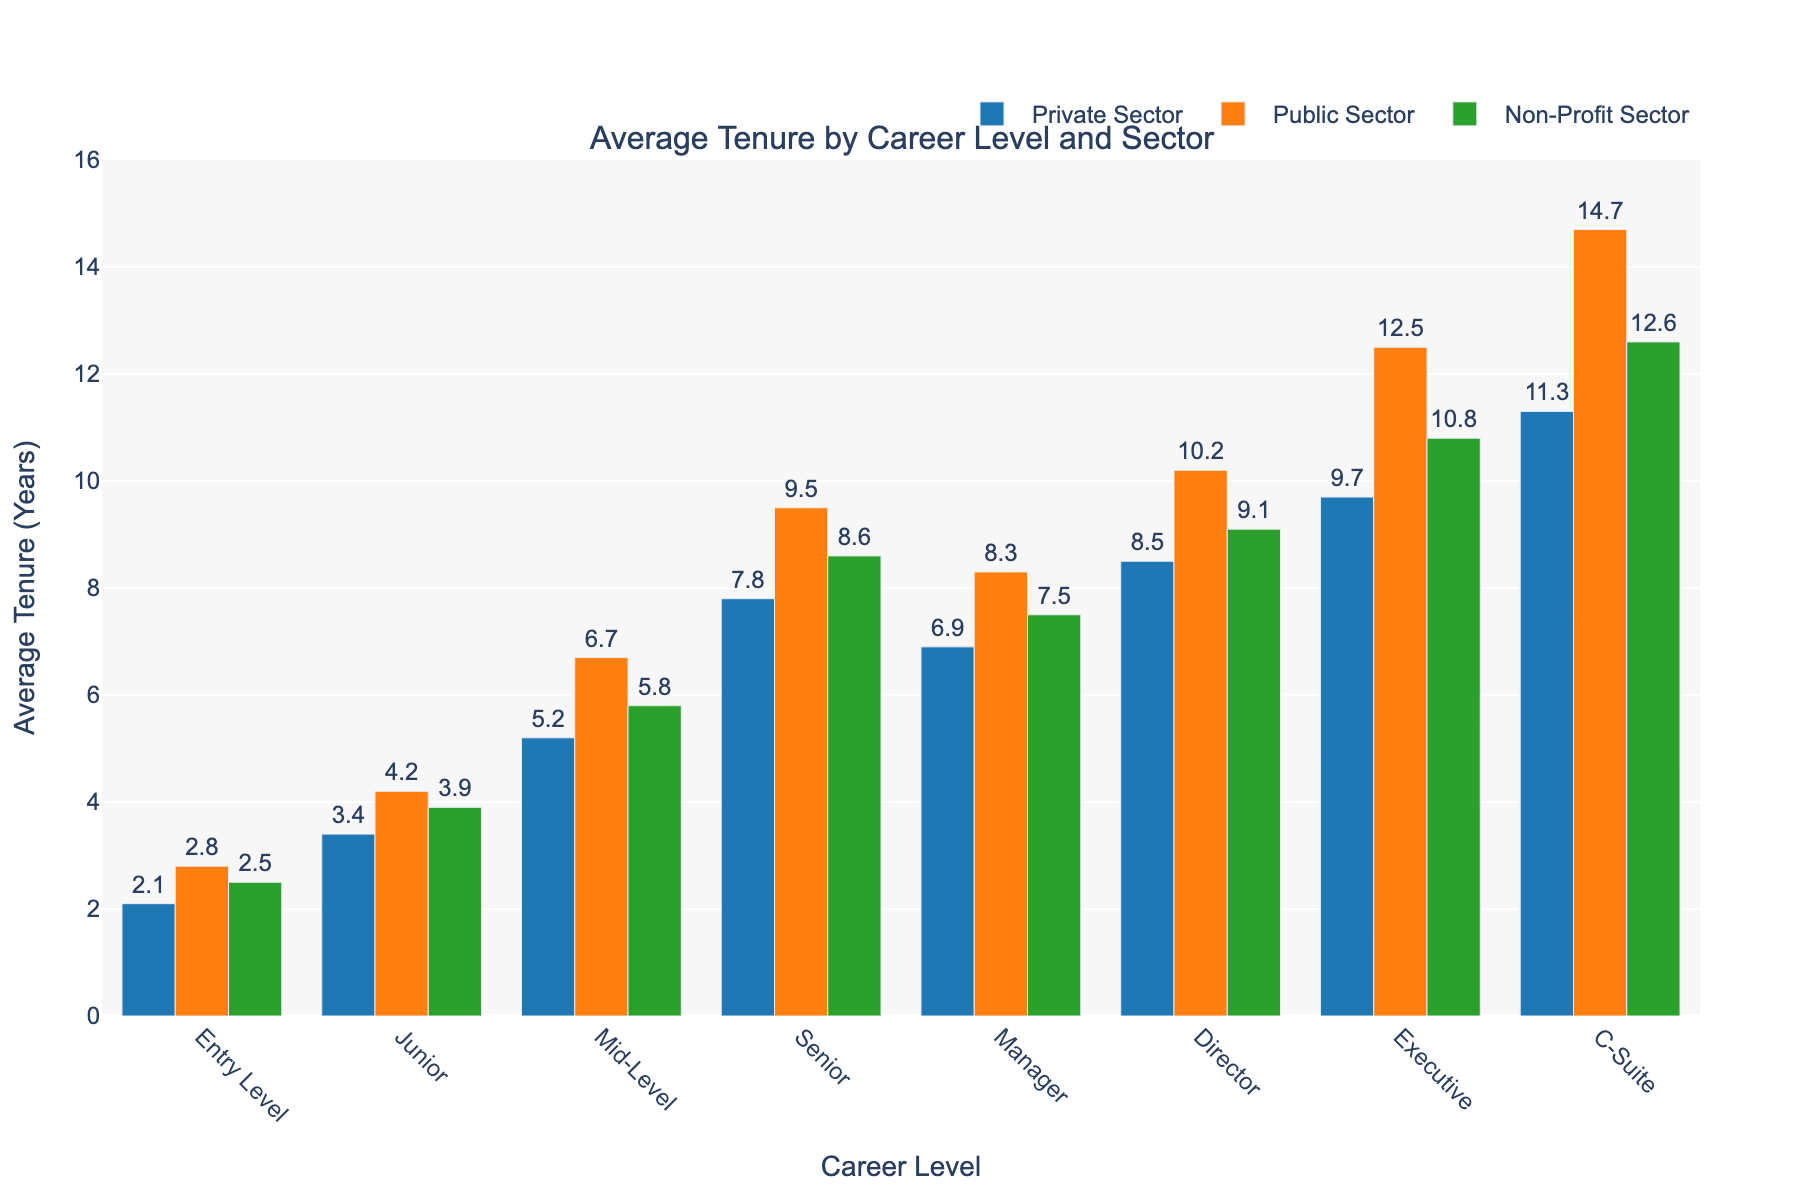What's the average tenure for a Senior level position across all sectors? Sum the average tenures of Senior level positions across Private, Public, and Non-Profit sectors: (7.8 + 9.5 + 8.6) = 25.9 years. Then, divide by the number of sectors (3): 25.9 / 3 = 8.6 years
Answer: 8.6 Which career level has the highest average tenure in the Public Sector? Compare the bar heights for the Public Sector across all career levels. The tallest bar represents the C-Suite with an average tenure of 14.7 years.
Answer: C-Suite How much longer is the average tenure of executives in the Public Sector compared to the Private Sector? Subtract the average tenure of executives in the Private Sector (9.7 years) from the average tenure in the Public Sector (12.5 years): 12.5 - 9.7 = 2.8 years
Answer: 2.8 Which sector exhibits the most consistent increase in average tenure from Entry Level to C-Suite? Observe and compare the gradient of the bars from Entry Level to C-Suite for each sector. The Public Sector shows a steady increase in average tenure from 2.8 to 14.7 years.
Answer: Public Sector What is the difference in average tenure between a Manager in the Non-Profit sector and a Junior position in the Public Sector? Subtract the average tenure of a Junior position in the Public Sector (4.2 years) from the average tenure of a Manager in the Non-Profit sector (7.5 years): 7.5 - 4.2 = 3.3 years
Answer: 3.3 How does the average tenure of Directors compare across all sectors? Compare the bar heights for Directors in Private (8.5 years), Public (10.2 years), and Non-Profit (9.1 years) sectors. The Public sector has the highest, followed by Non-Profit and Private sectors.
Answer: Public > Non-Profit > Private What is the combined average tenure of Mid-Level employees across the Private and Non-Profit sectors? Sum the average tenures of Mid-Level employees in the Private and Non-Profit sectors: 5.2 (Private) + 5.8 (Non-Profit) = 11 years
Answer: 11 Which career level in the Private Sector has the shortest average tenure? Compare the bar heights for all career levels within the Private Sector. Entry Level has the shortest average tenure at 2.1 years.
Answer: Entry Level By how many years does the average tenure of a Director in the Public Sector exceed that of a Manager in the Private Sector? Subtract the average tenure of a Manager in the Private Sector (6.9 years) from the average tenure of a Director in the Public Sector (10.2 years): 10.2 - 6.9 = 3.3 years
Answer: 3.3 What's the range of average tenures for Entry Level positions across all sectors? Identify the highest and lowest average tenures for Entry Level positions across all sectors: 2.8 years (Public) - 2.1 years (Private) = 0.7 years
Answer: 0.7 